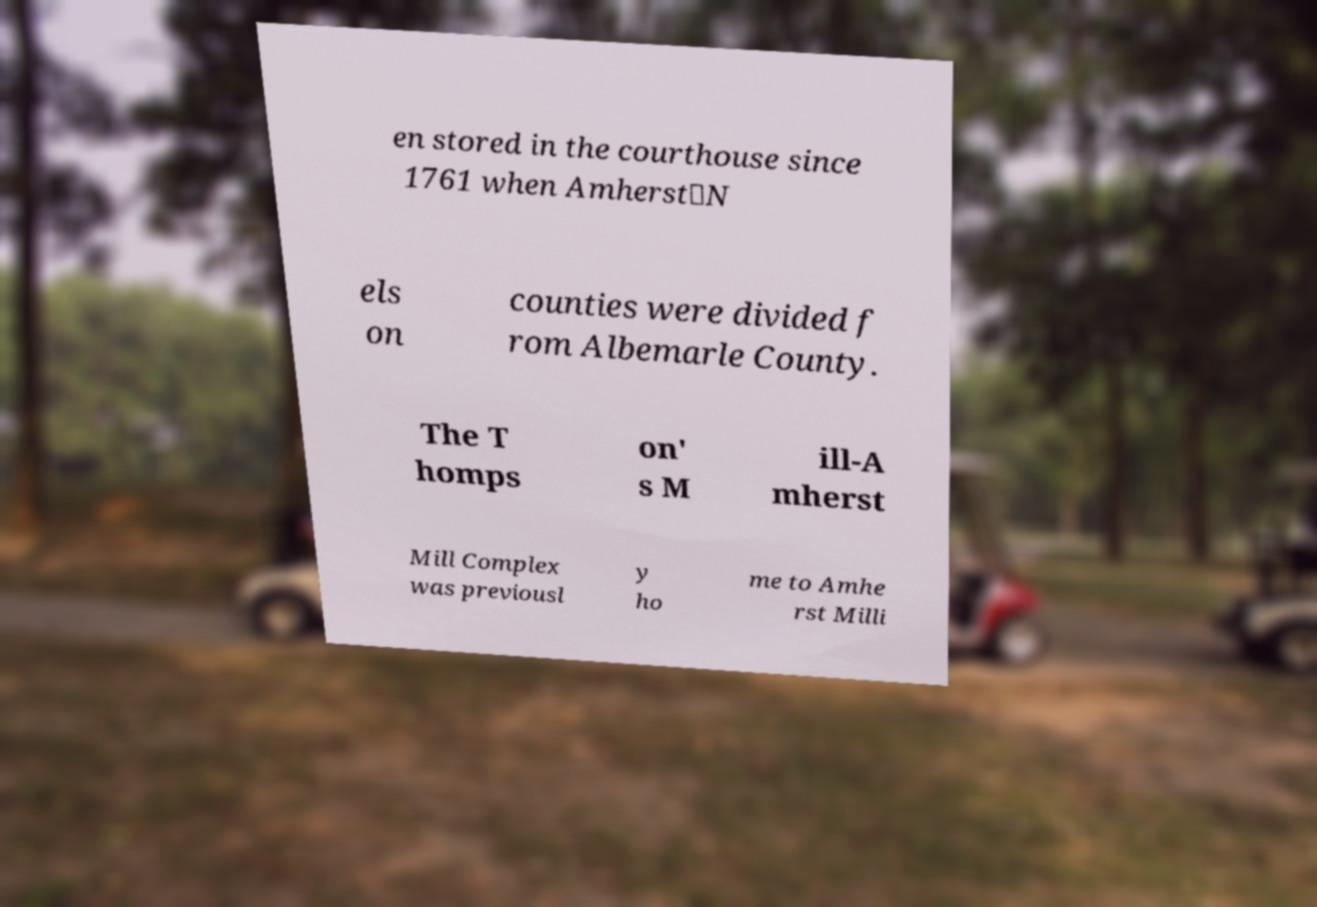Please identify and transcribe the text found in this image. en stored in the courthouse since 1761 when Amherst‑N els on counties were divided f rom Albemarle County. The T homps on' s M ill-A mherst Mill Complex was previousl y ho me to Amhe rst Milli 